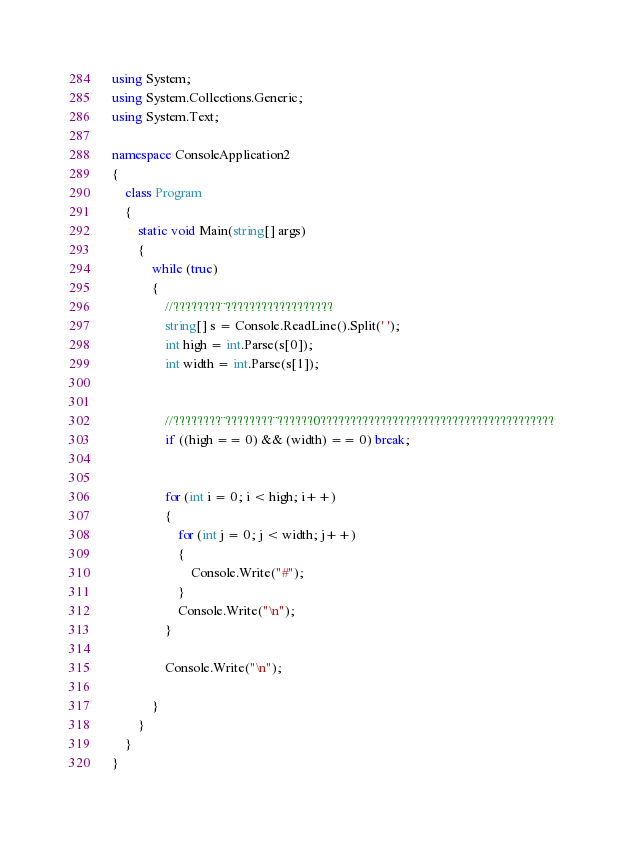Convert code to text. <code><loc_0><loc_0><loc_500><loc_500><_C#_>using System;
using System.Collections.Generic;
using System.Text;

namespace ConsoleApplication2
{
    class Program
    {
        static void Main(string[] args)
        {
            while (true)
            {
                //????????¨??????????????????
                string[] s = Console.ReadLine().Split(' ');
                int high = int.Parse(s[0]);
                int width = int.Parse(s[1]);


                //????????¨????????¨??????0???????????????????????????????????????
                if ((high == 0) && (width) == 0) break;


                for (int i = 0; i < high; i++)
                {
                    for (int j = 0; j < width; j++)
                    {
                        Console.Write("#");
                    }
                    Console.Write("\n");
                }

                Console.Write("\n");

            }
        }
    }
}</code> 